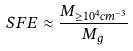<formula> <loc_0><loc_0><loc_500><loc_500>S F E \approx \frac { M _ { \geq 1 0 ^ { 4 } c m ^ { - 3 } } } { M _ { g } }</formula> 